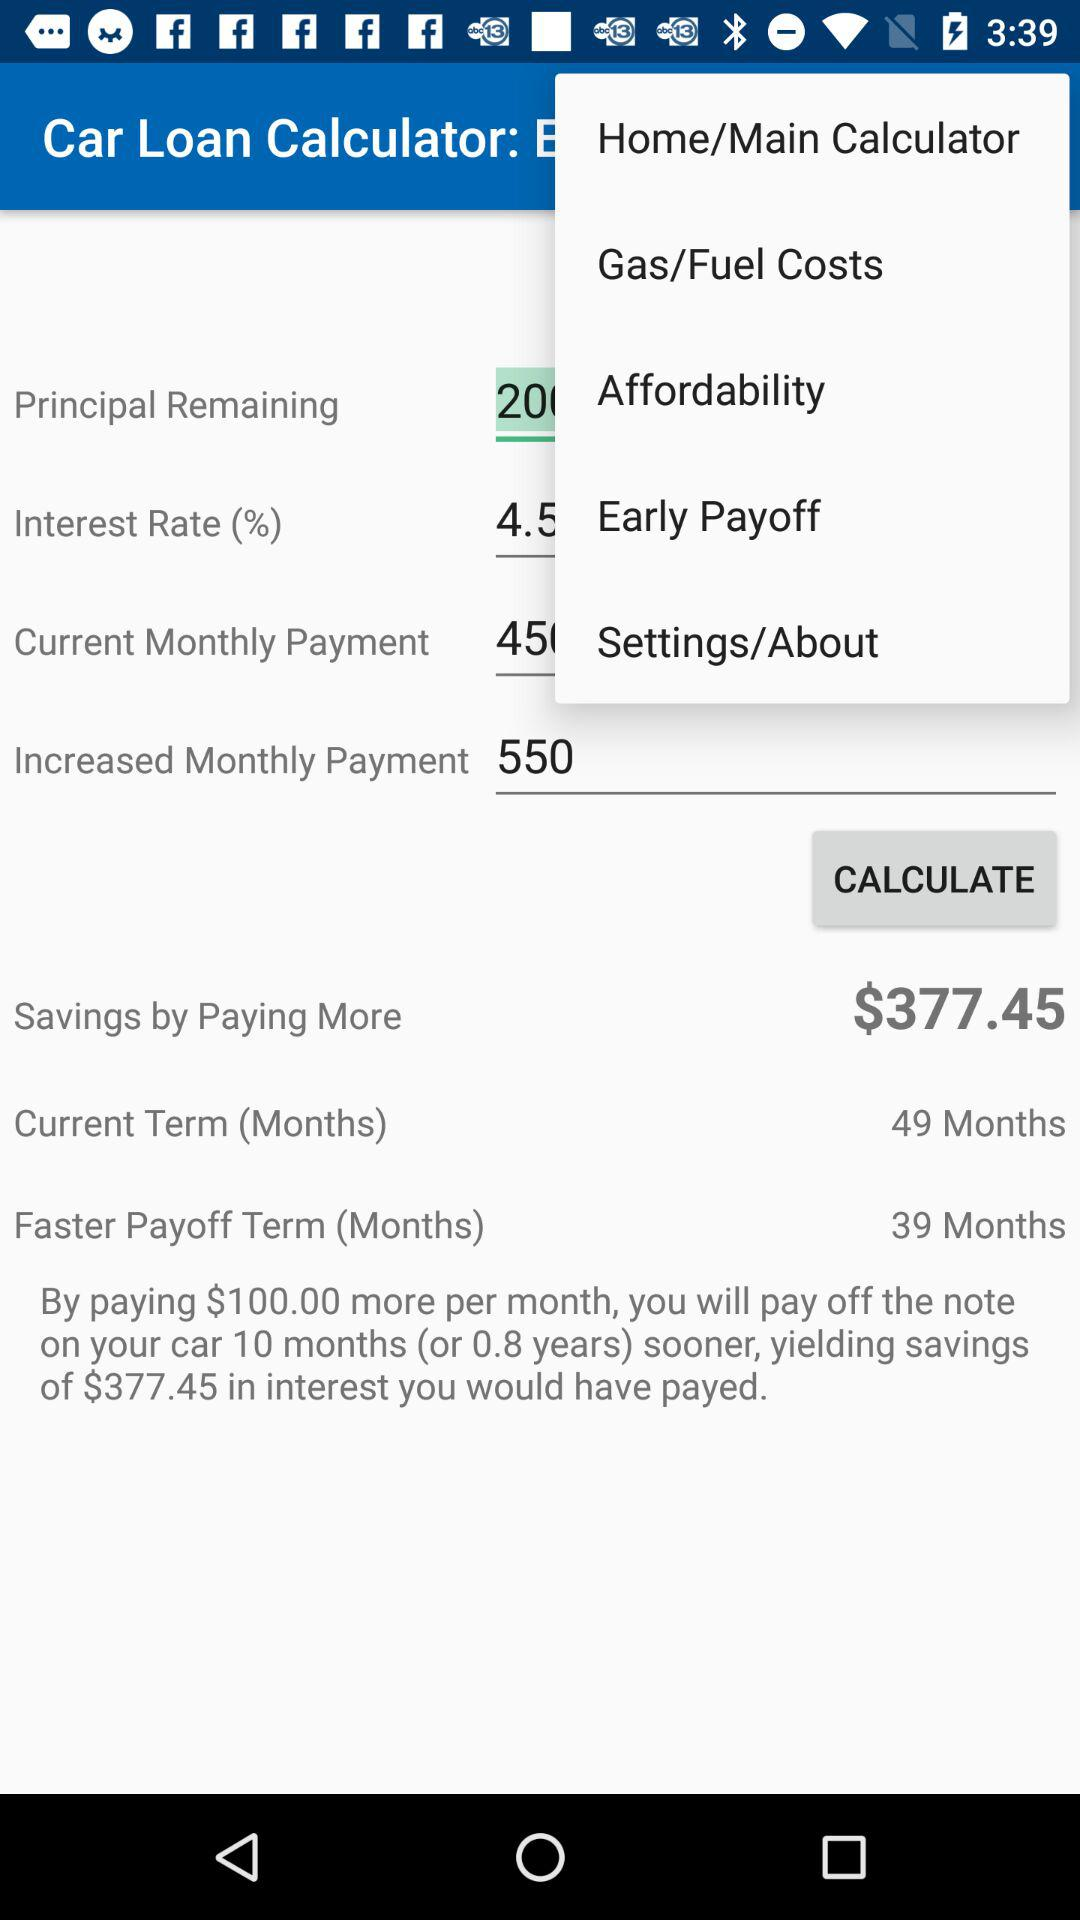How many months are there in the current term? There are 49 months in the current term. 